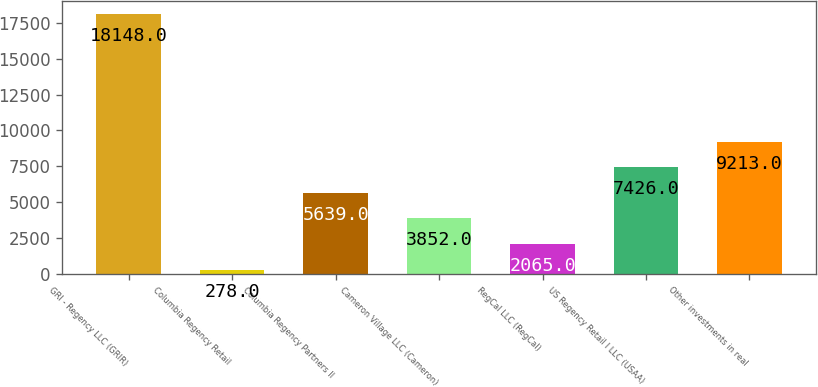Convert chart to OTSL. <chart><loc_0><loc_0><loc_500><loc_500><bar_chart><fcel>GRI - Regency LLC (GRIR)<fcel>Columbia Regency Retail<fcel>Columbia Regency Partners II<fcel>Cameron Village LLC (Cameron)<fcel>RegCal LLC (RegCal)<fcel>US Regency Retail I LLC (USAA)<fcel>Other investments in real<nl><fcel>18148<fcel>278<fcel>5639<fcel>3852<fcel>2065<fcel>7426<fcel>9213<nl></chart> 